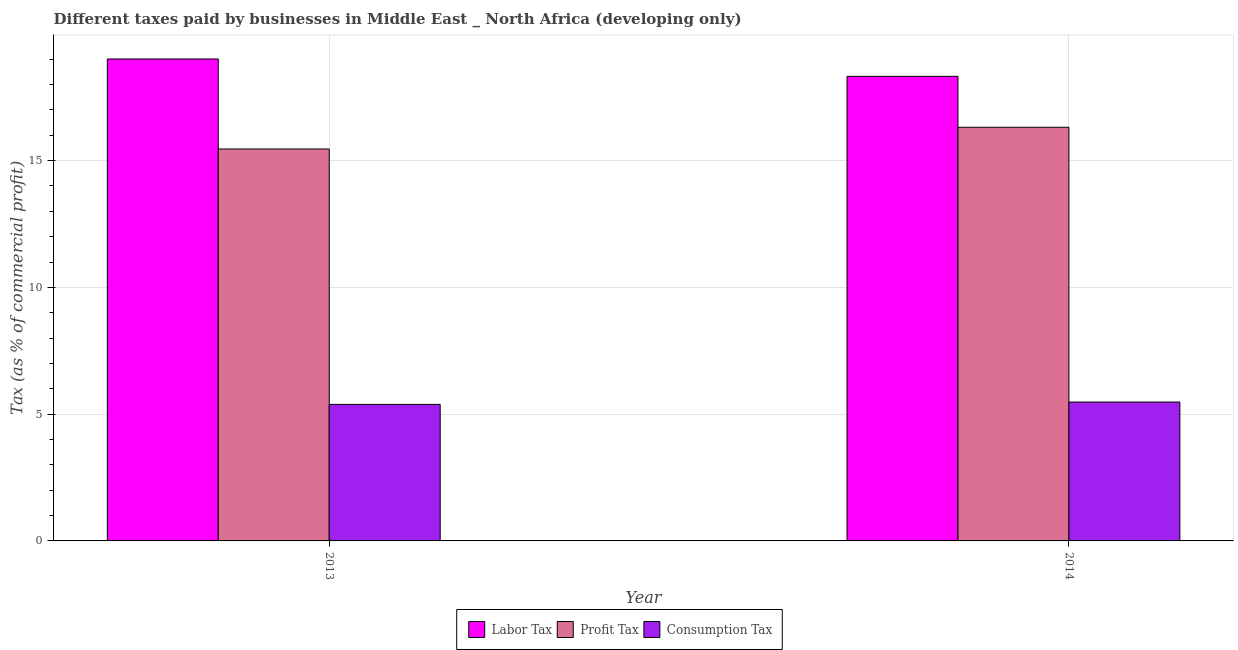How many different coloured bars are there?
Give a very brief answer. 3. How many groups of bars are there?
Make the answer very short. 2. How many bars are there on the 1st tick from the left?
Your response must be concise. 3. What is the label of the 1st group of bars from the left?
Keep it short and to the point. 2013. In how many cases, is the number of bars for a given year not equal to the number of legend labels?
Offer a terse response. 0. What is the percentage of consumption tax in 2013?
Provide a short and direct response. 5.38. Across all years, what is the maximum percentage of profit tax?
Give a very brief answer. 16.32. Across all years, what is the minimum percentage of profit tax?
Give a very brief answer. 15.46. What is the total percentage of profit tax in the graph?
Your response must be concise. 31.77. What is the difference between the percentage of consumption tax in 2013 and that in 2014?
Your answer should be very brief. -0.09. What is the difference between the percentage of labor tax in 2013 and the percentage of consumption tax in 2014?
Give a very brief answer. 0.69. What is the average percentage of profit tax per year?
Your answer should be very brief. 15.89. In the year 2013, what is the difference between the percentage of profit tax and percentage of consumption tax?
Your answer should be very brief. 0. What is the ratio of the percentage of labor tax in 2013 to that in 2014?
Your answer should be very brief. 1.04. In how many years, is the percentage of labor tax greater than the average percentage of labor tax taken over all years?
Give a very brief answer. 1. What does the 3rd bar from the left in 2013 represents?
Provide a short and direct response. Consumption Tax. What does the 1st bar from the right in 2014 represents?
Offer a very short reply. Consumption Tax. What is the difference between two consecutive major ticks on the Y-axis?
Offer a terse response. 5. Are the values on the major ticks of Y-axis written in scientific E-notation?
Keep it short and to the point. No. Does the graph contain grids?
Provide a succinct answer. Yes. Where does the legend appear in the graph?
Provide a succinct answer. Bottom center. What is the title of the graph?
Give a very brief answer. Different taxes paid by businesses in Middle East _ North Africa (developing only). Does "Czech Republic" appear as one of the legend labels in the graph?
Your answer should be very brief. No. What is the label or title of the Y-axis?
Offer a very short reply. Tax (as % of commercial profit). What is the Tax (as % of commercial profit) of Labor Tax in 2013?
Offer a very short reply. 19.01. What is the Tax (as % of commercial profit) of Profit Tax in 2013?
Ensure brevity in your answer.  15.46. What is the Tax (as % of commercial profit) in Consumption Tax in 2013?
Ensure brevity in your answer.  5.38. What is the Tax (as % of commercial profit) of Labor Tax in 2014?
Provide a succinct answer. 18.32. What is the Tax (as % of commercial profit) of Profit Tax in 2014?
Your response must be concise. 16.32. What is the Tax (as % of commercial profit) of Consumption Tax in 2014?
Offer a terse response. 5.48. Across all years, what is the maximum Tax (as % of commercial profit) of Labor Tax?
Offer a terse response. 19.01. Across all years, what is the maximum Tax (as % of commercial profit) in Profit Tax?
Your answer should be very brief. 16.32. Across all years, what is the maximum Tax (as % of commercial profit) in Consumption Tax?
Provide a short and direct response. 5.48. Across all years, what is the minimum Tax (as % of commercial profit) of Labor Tax?
Provide a succinct answer. 18.32. Across all years, what is the minimum Tax (as % of commercial profit) in Profit Tax?
Keep it short and to the point. 15.46. Across all years, what is the minimum Tax (as % of commercial profit) of Consumption Tax?
Provide a short and direct response. 5.38. What is the total Tax (as % of commercial profit) in Labor Tax in the graph?
Your answer should be compact. 37.33. What is the total Tax (as % of commercial profit) in Profit Tax in the graph?
Ensure brevity in your answer.  31.77. What is the total Tax (as % of commercial profit) in Consumption Tax in the graph?
Offer a very short reply. 10.86. What is the difference between the Tax (as % of commercial profit) of Labor Tax in 2013 and that in 2014?
Your answer should be very brief. 0.69. What is the difference between the Tax (as % of commercial profit) of Profit Tax in 2013 and that in 2014?
Your answer should be compact. -0.86. What is the difference between the Tax (as % of commercial profit) of Consumption Tax in 2013 and that in 2014?
Provide a short and direct response. -0.09. What is the difference between the Tax (as % of commercial profit) in Labor Tax in 2013 and the Tax (as % of commercial profit) in Profit Tax in 2014?
Make the answer very short. 2.69. What is the difference between the Tax (as % of commercial profit) of Labor Tax in 2013 and the Tax (as % of commercial profit) of Consumption Tax in 2014?
Your answer should be very brief. 13.53. What is the difference between the Tax (as % of commercial profit) of Profit Tax in 2013 and the Tax (as % of commercial profit) of Consumption Tax in 2014?
Provide a short and direct response. 9.98. What is the average Tax (as % of commercial profit) of Labor Tax per year?
Offer a very short reply. 18.67. What is the average Tax (as % of commercial profit) in Profit Tax per year?
Your answer should be very brief. 15.89. What is the average Tax (as % of commercial profit) in Consumption Tax per year?
Your response must be concise. 5.43. In the year 2013, what is the difference between the Tax (as % of commercial profit) of Labor Tax and Tax (as % of commercial profit) of Profit Tax?
Make the answer very short. 3.55. In the year 2013, what is the difference between the Tax (as % of commercial profit) in Labor Tax and Tax (as % of commercial profit) in Consumption Tax?
Offer a terse response. 13.62. In the year 2013, what is the difference between the Tax (as % of commercial profit) in Profit Tax and Tax (as % of commercial profit) in Consumption Tax?
Offer a very short reply. 10.07. In the year 2014, what is the difference between the Tax (as % of commercial profit) in Labor Tax and Tax (as % of commercial profit) in Profit Tax?
Provide a succinct answer. 2.01. In the year 2014, what is the difference between the Tax (as % of commercial profit) of Labor Tax and Tax (as % of commercial profit) of Consumption Tax?
Keep it short and to the point. 12.85. In the year 2014, what is the difference between the Tax (as % of commercial profit) of Profit Tax and Tax (as % of commercial profit) of Consumption Tax?
Provide a short and direct response. 10.84. What is the ratio of the Tax (as % of commercial profit) in Labor Tax in 2013 to that in 2014?
Give a very brief answer. 1.04. What is the ratio of the Tax (as % of commercial profit) of Profit Tax in 2013 to that in 2014?
Ensure brevity in your answer.  0.95. What is the ratio of the Tax (as % of commercial profit) of Consumption Tax in 2013 to that in 2014?
Make the answer very short. 0.98. What is the difference between the highest and the second highest Tax (as % of commercial profit) in Labor Tax?
Give a very brief answer. 0.69. What is the difference between the highest and the second highest Tax (as % of commercial profit) of Profit Tax?
Keep it short and to the point. 0.86. What is the difference between the highest and the second highest Tax (as % of commercial profit) of Consumption Tax?
Offer a very short reply. 0.09. What is the difference between the highest and the lowest Tax (as % of commercial profit) of Labor Tax?
Provide a succinct answer. 0.69. What is the difference between the highest and the lowest Tax (as % of commercial profit) in Profit Tax?
Your answer should be compact. 0.86. What is the difference between the highest and the lowest Tax (as % of commercial profit) in Consumption Tax?
Offer a terse response. 0.09. 